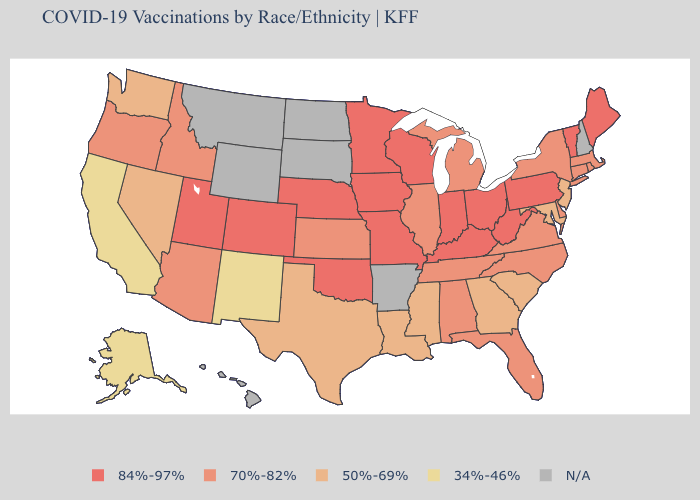What is the lowest value in the Northeast?
Short answer required. 50%-69%. Does Vermont have the lowest value in the Northeast?
Be succinct. No. Name the states that have a value in the range N/A?
Give a very brief answer. Arkansas, Hawaii, Montana, New Hampshire, North Dakota, South Dakota, Wyoming. Which states have the highest value in the USA?
Answer briefly. Colorado, Indiana, Iowa, Kentucky, Maine, Minnesota, Missouri, Nebraska, Ohio, Oklahoma, Pennsylvania, Utah, Vermont, West Virginia, Wisconsin. What is the highest value in the USA?
Keep it brief. 84%-97%. Among the states that border North Carolina , does South Carolina have the highest value?
Concise answer only. No. What is the value of Arkansas?
Concise answer only. N/A. What is the value of Maryland?
Answer briefly. 50%-69%. What is the highest value in the USA?
Keep it brief. 84%-97%. What is the lowest value in the West?
Quick response, please. 34%-46%. How many symbols are there in the legend?
Keep it brief. 5. Name the states that have a value in the range 84%-97%?
Write a very short answer. Colorado, Indiana, Iowa, Kentucky, Maine, Minnesota, Missouri, Nebraska, Ohio, Oklahoma, Pennsylvania, Utah, Vermont, West Virginia, Wisconsin. How many symbols are there in the legend?
Answer briefly. 5. 